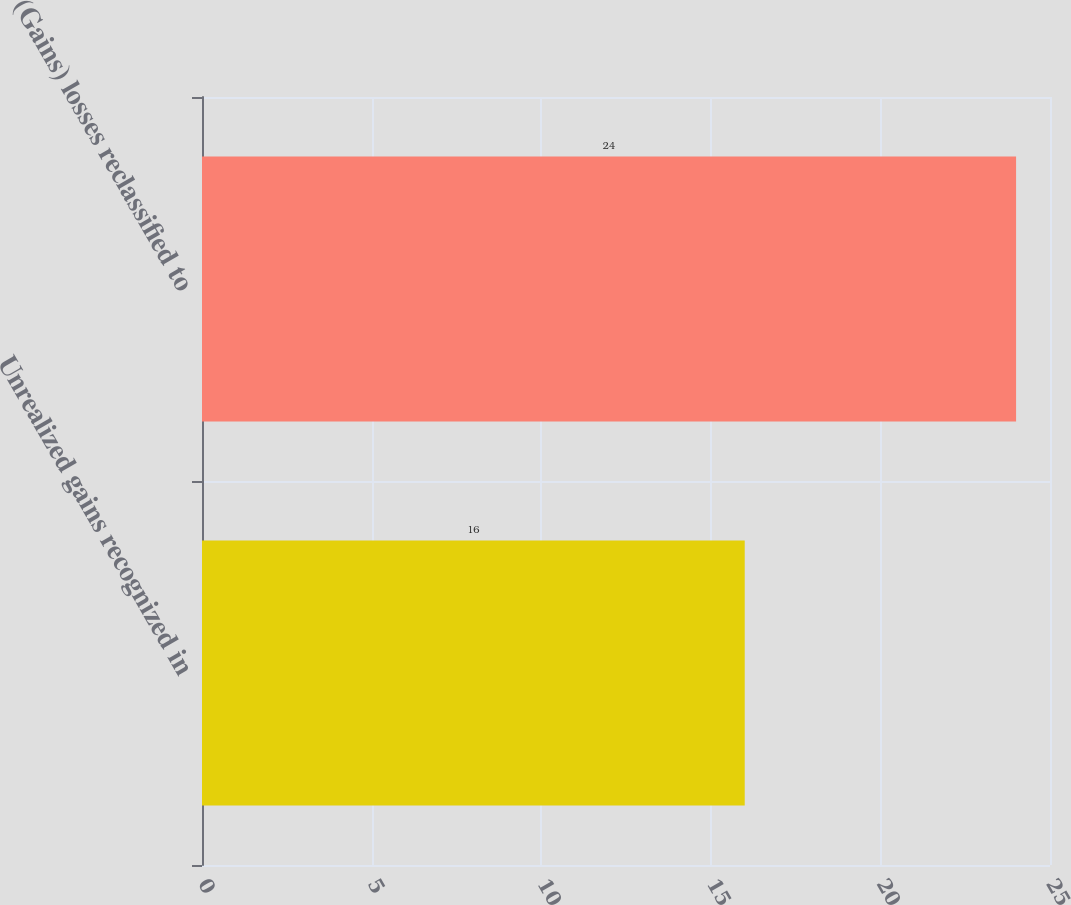Convert chart. <chart><loc_0><loc_0><loc_500><loc_500><bar_chart><fcel>Unrealized gains recognized in<fcel>(Gains) losses reclassified to<nl><fcel>16<fcel>24<nl></chart> 